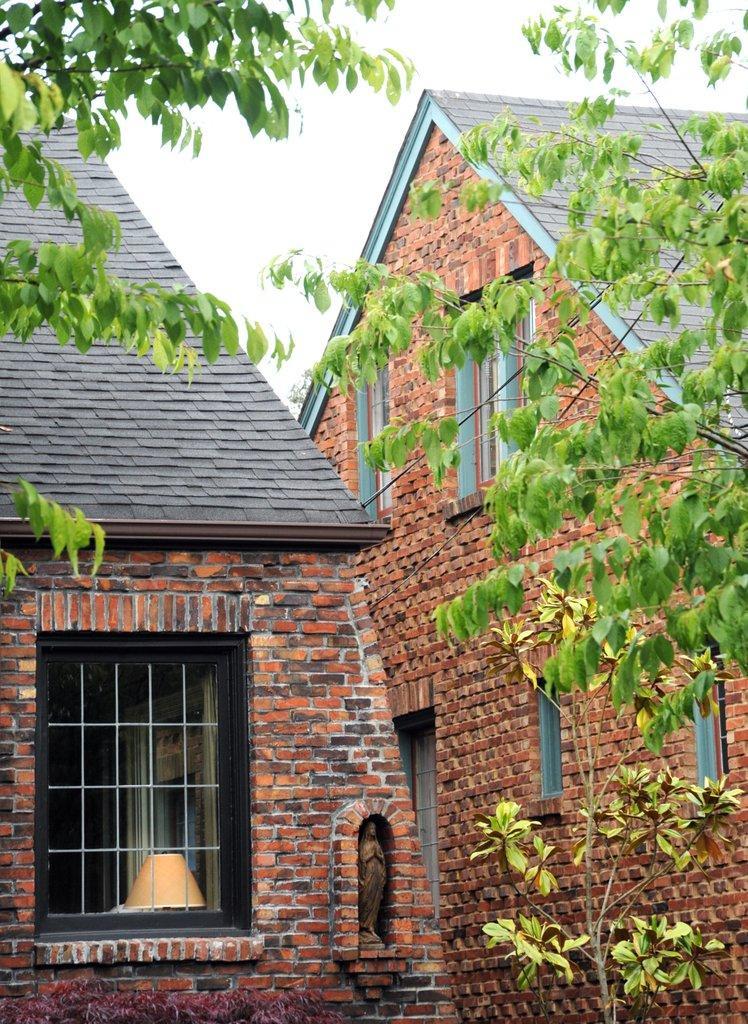Describe this image in one or two sentences. In this image we can see a house with a roof and some windows. We can also a statue and a lamp. On the backside we can see some plants and the sky which looks cloudy. 